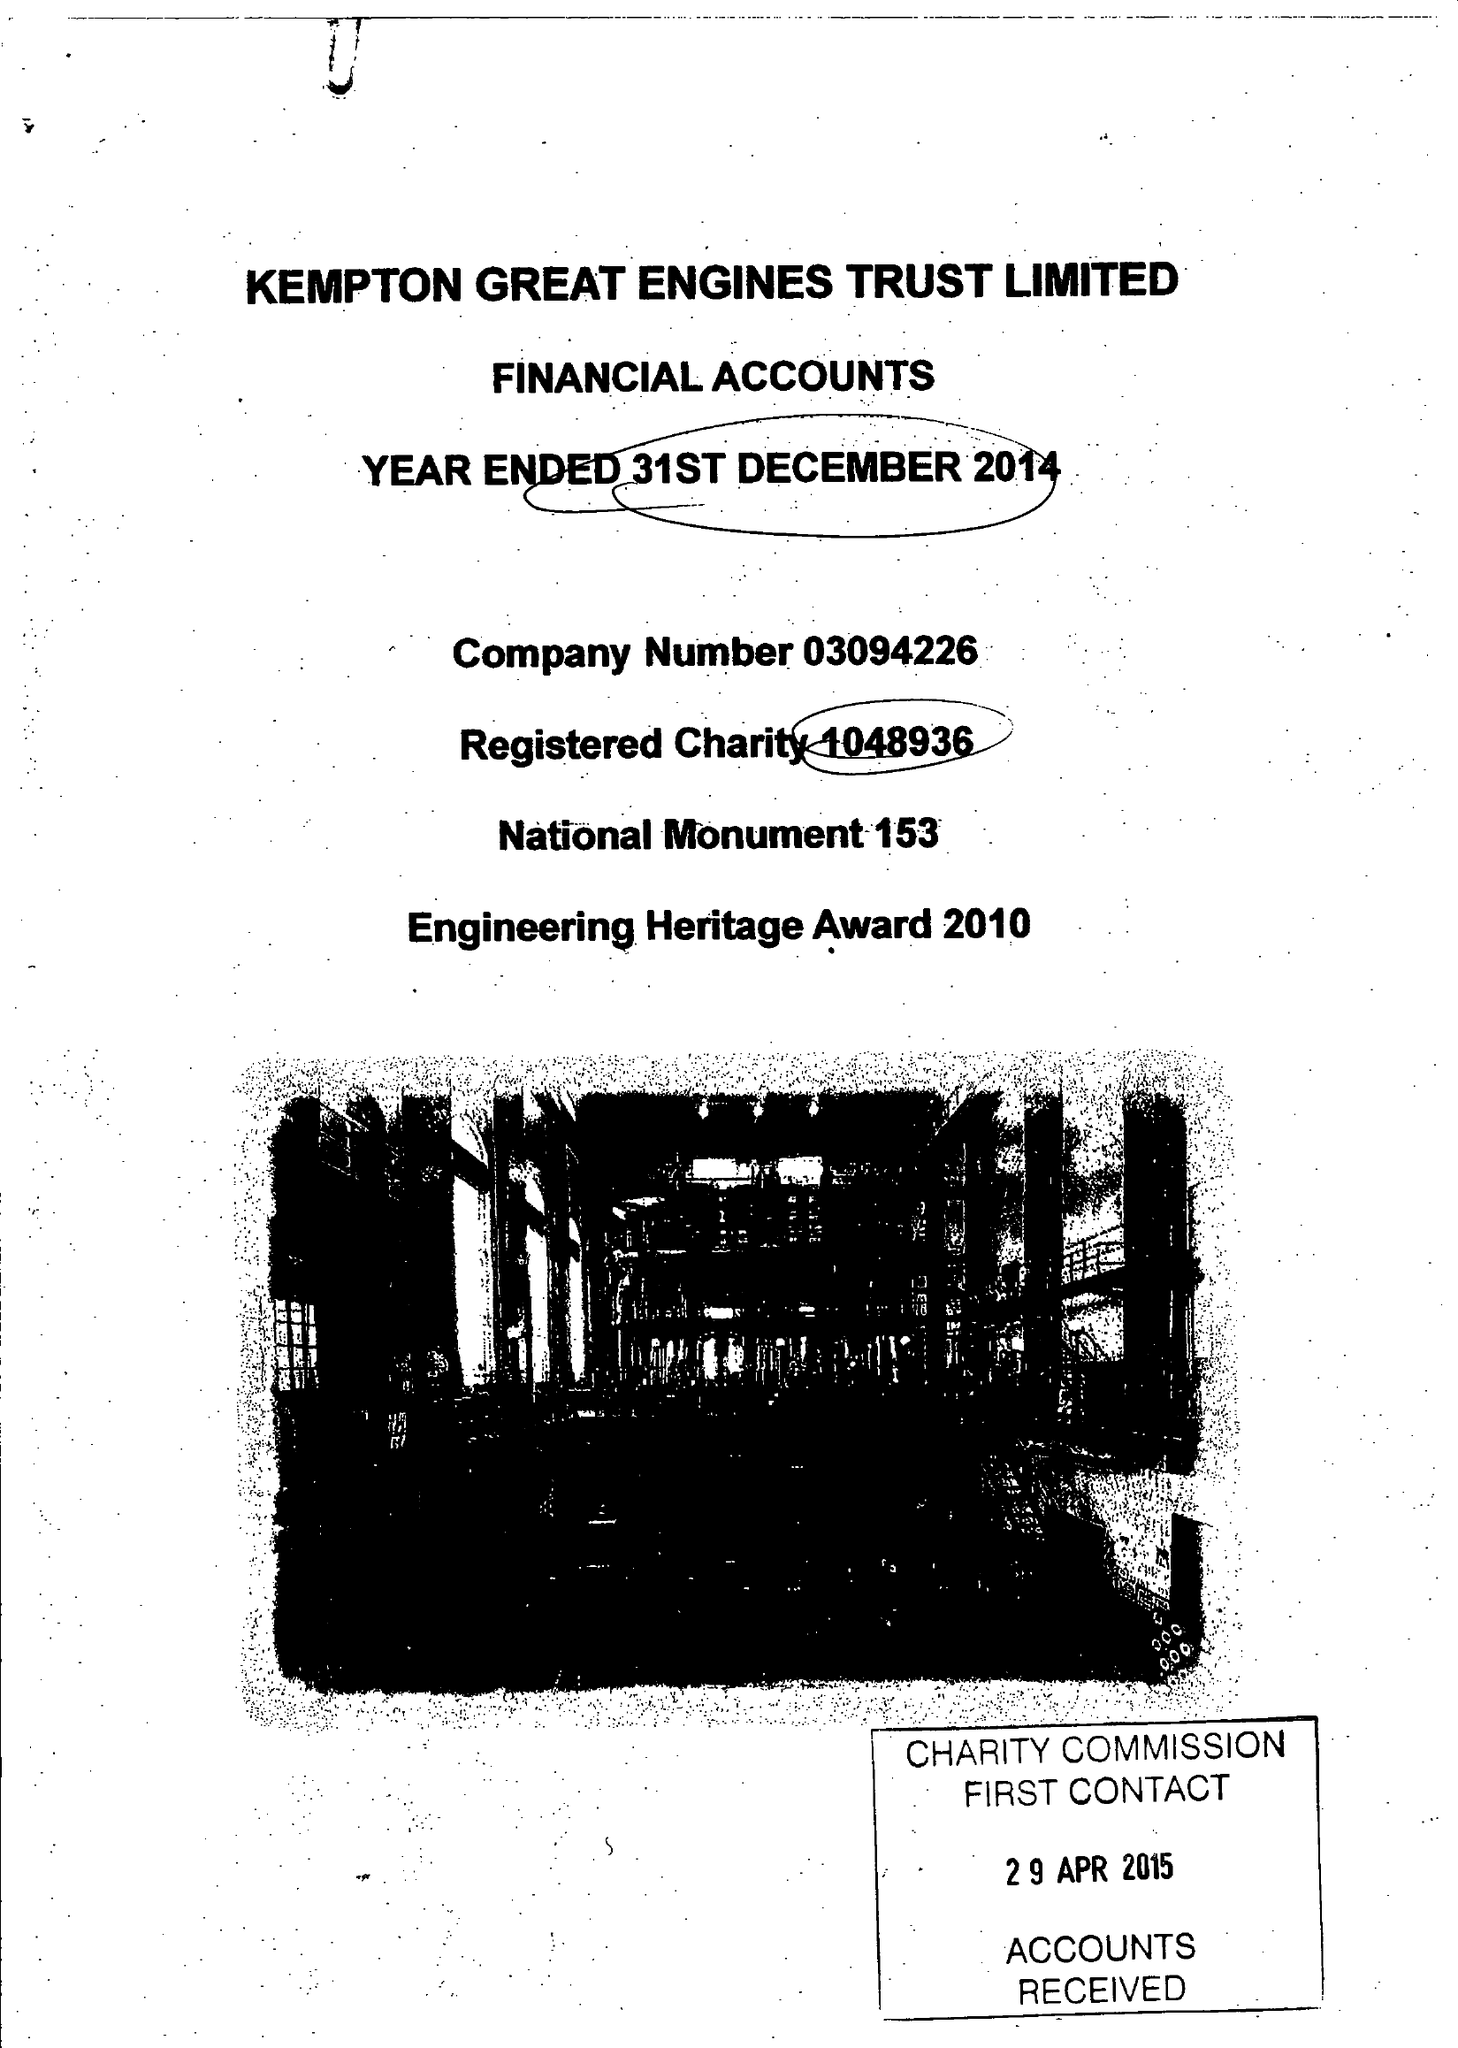What is the value for the charity_name?
Answer the question using a single word or phrase. Kempton Great Engines Trust Ltd. 